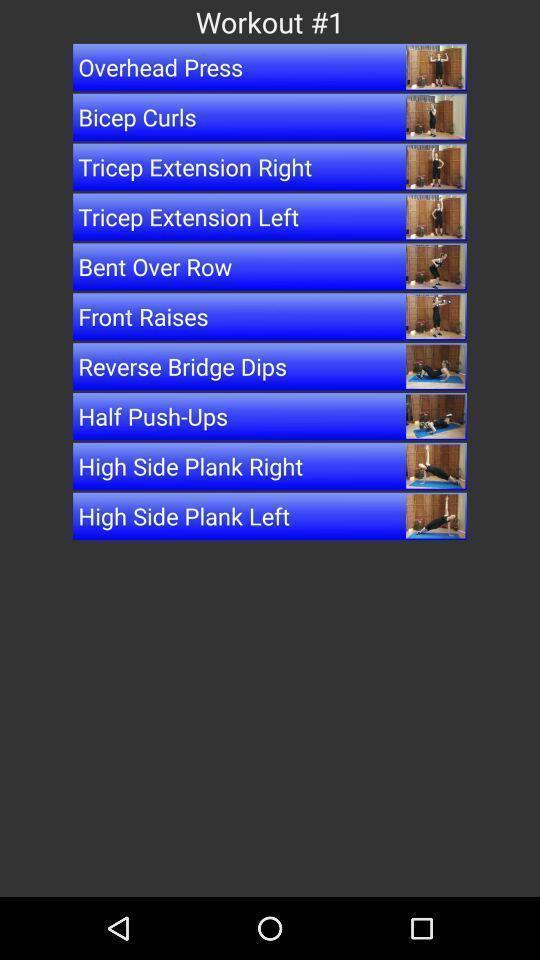Describe the key features of this screenshot. Screen displaying a list of workout exercises. 